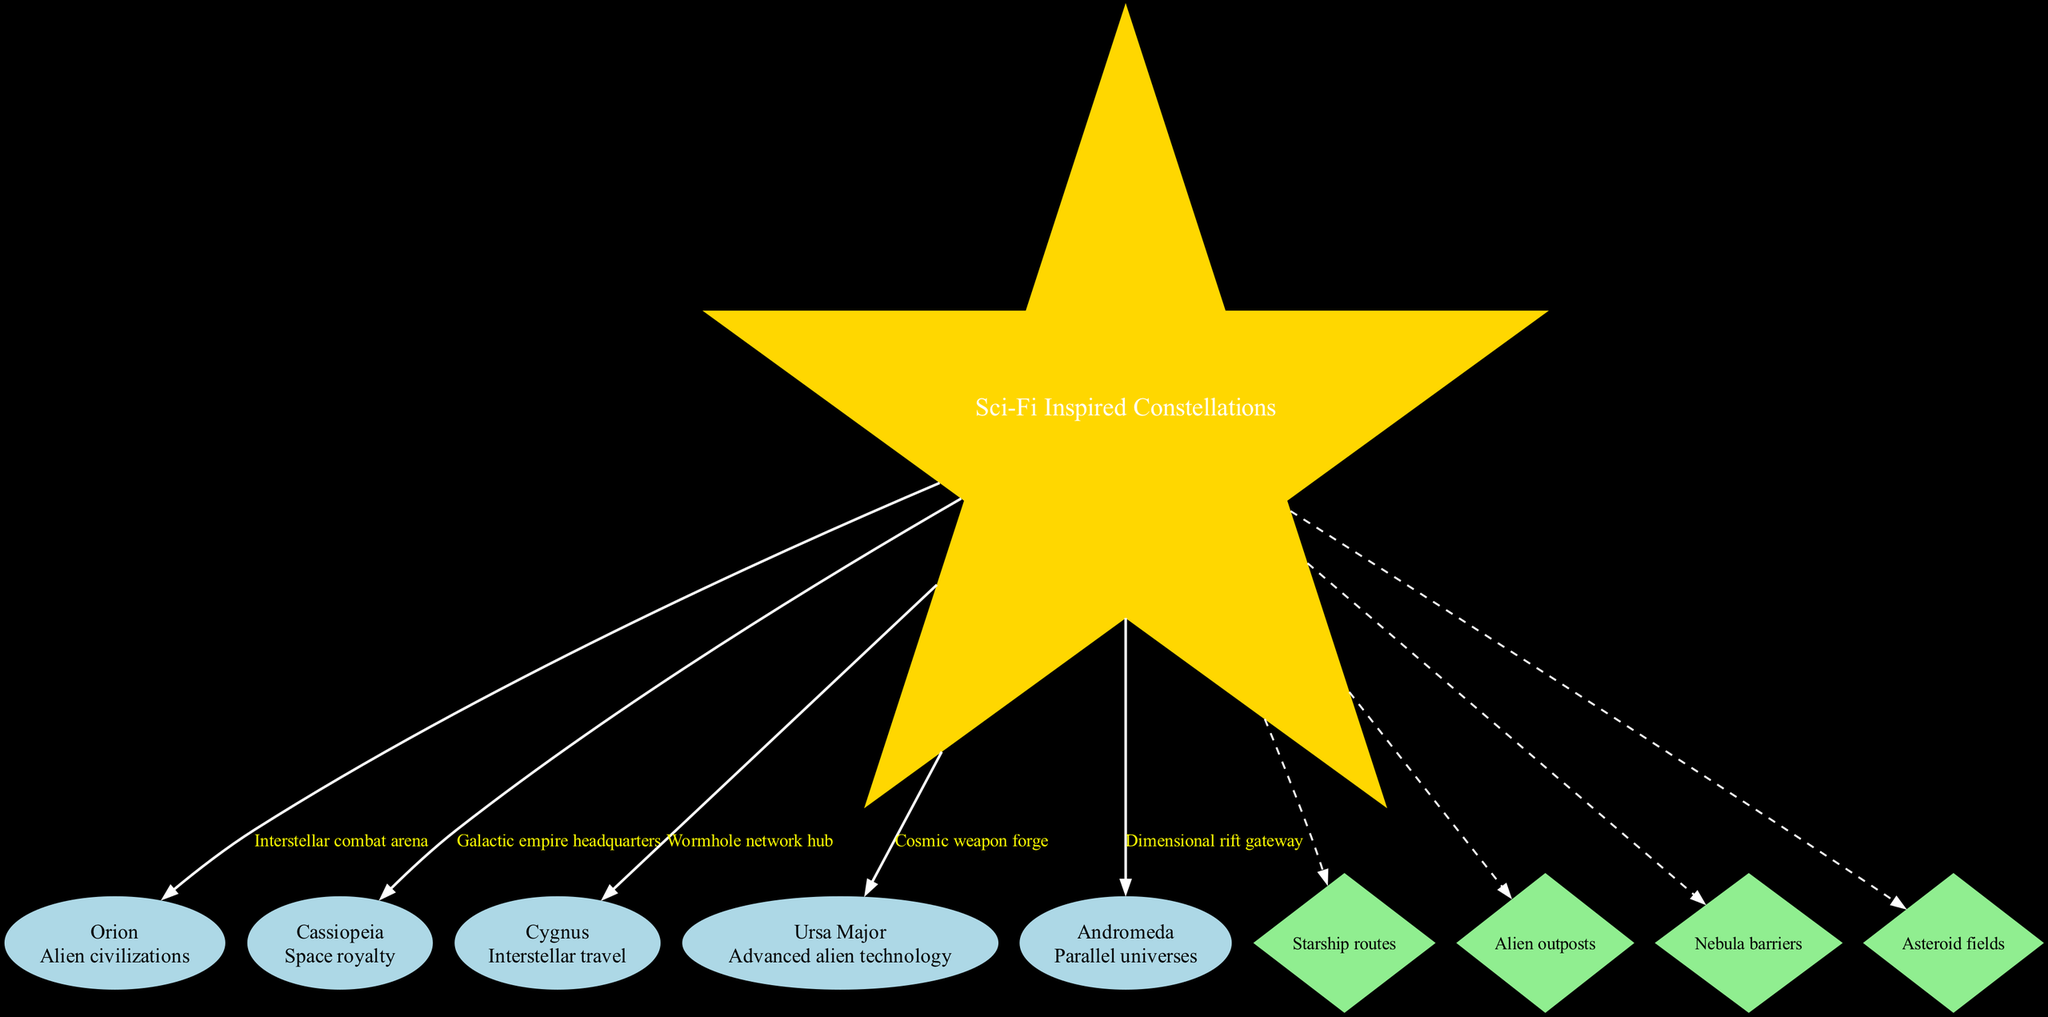What is the central theme of the diagram? The central theme node in the diagram labeled "Sci-Fi Inspired Constellations" indicates what the diagram is focused on, providing the main idea around which the constellations and elements are organized.
Answer: Sci-Fi Inspired Constellations How many constellations are featured in the diagram? By counting the number of nodes labeled with constellation names, we can determine the total number of constellations represented. There are five notable constellations shown.
Answer: 5 Which constellation is associated with "Parallel universes"? The diagram shows that the constellation "Andromeda" is directly linked to the concept of "Parallel universes," as indicated by the information next to its node.
Answer: Andromeda What game element is associated with the constellation "Orion"? The edge connecting the central theme to the "Orion" constellation specifies that it is related to an "Interstellar combat arena," making this information available from the corresponding edge label.
Answer: Interstellar combat arena Which connecting element is represented with a dashed line from the central theme? The connecting elements are shown as diamond-shaped nodes, connected to the central theme with dashed lines. For example, "Starship routes" is one of these connecting elements.
Answer: Starship routes How many connecting elements are linking out from the central theme? By assessing the number of diamond-shaped nodes that connect to the central theme, we can identify that there are four distinct connecting elements illustrated.
Answer: 4 What is the game element linked with "Advanced alien technology"? The connection from the "Ursa Major" constellation to the central theme specifies that it relates to a "Cosmic weapon forge," which is the game element concerning advanced technology.
Answer: Cosmic weapon forge Which two constellations share a similar sci-fi inspiration regarding travel? The constellation "Cygnus," inspired by "Interstellar travel," and the interconnected themes here imply an association as they both pertain to navigation dimensions, a concept threaded through strategies in sci-fi themes.
Answer: Cygnus and Andromeda 